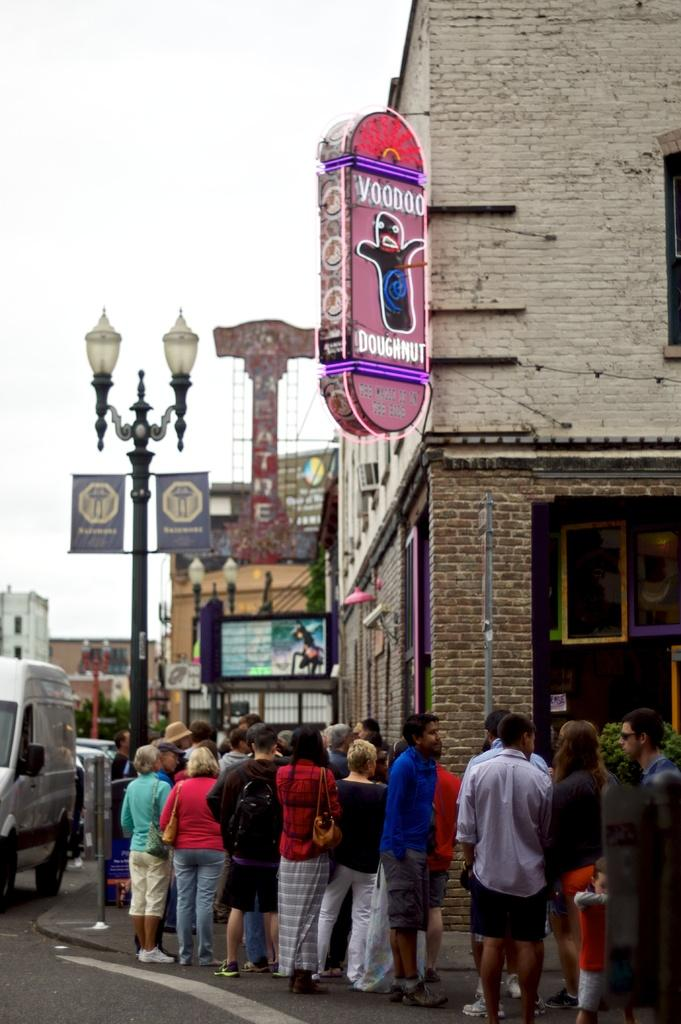What can be seen in the foreground of the image? There are people standing in front of the road in the image. What is happening on the road? There are vehicles on the road in the image. What structures are present in the image? There are light poles in the image. What is attached to the building? There are boards attached to the building in the image. What is visible in the background of the image? The sky is visible in the background of the image. Where is the library located in the image? There is no library present in the image. Is the crook trying to steal the vehicles on the road in the image? There is no crook present in the image, and therefore no such activity can be observed. 